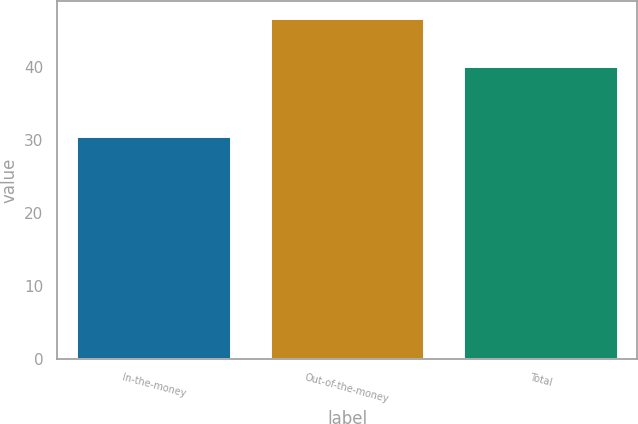Convert chart. <chart><loc_0><loc_0><loc_500><loc_500><bar_chart><fcel>In-the-money<fcel>Out-of-the-money<fcel>Total<nl><fcel>30.61<fcel>46.83<fcel>40.14<nl></chart> 